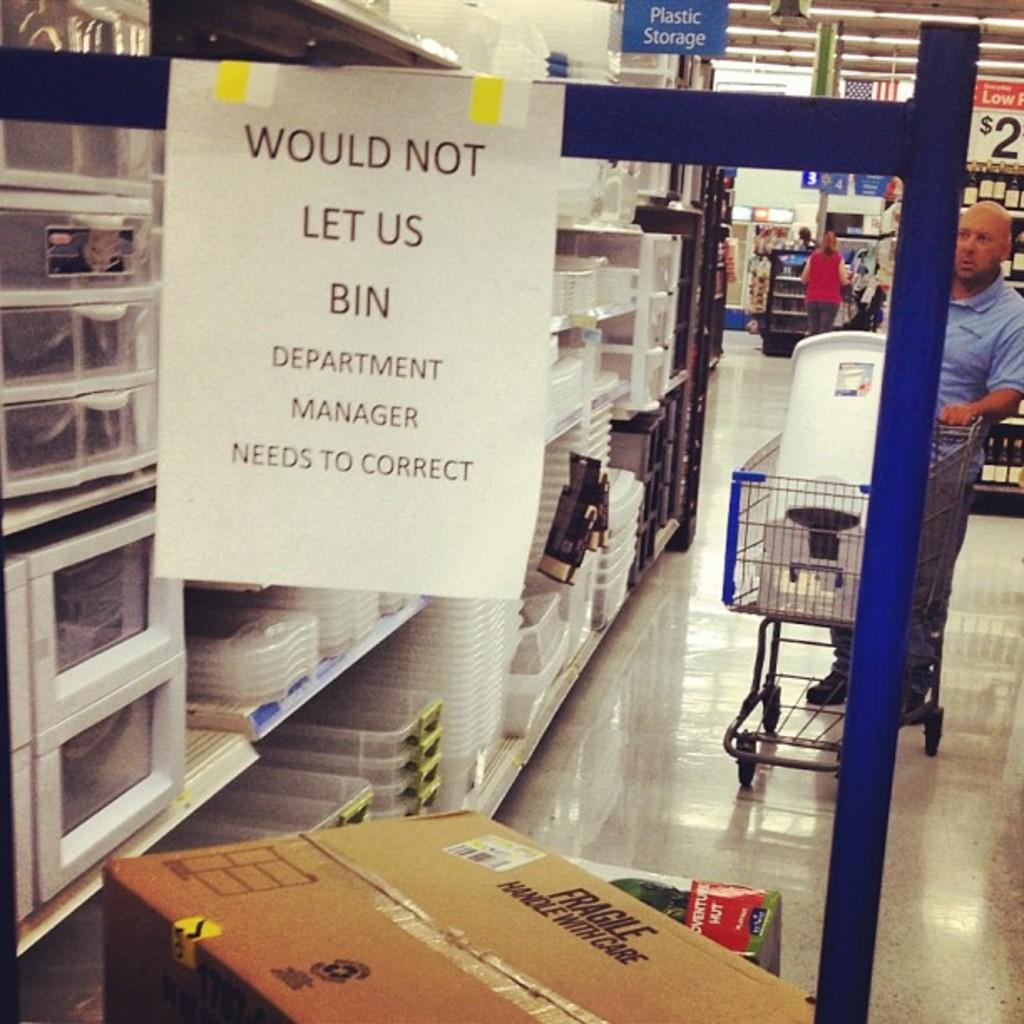<image>
Describe the image concisely. In a warehouse type store, a sign over a cardboard box reads WOULD NOT LET US BIN. 